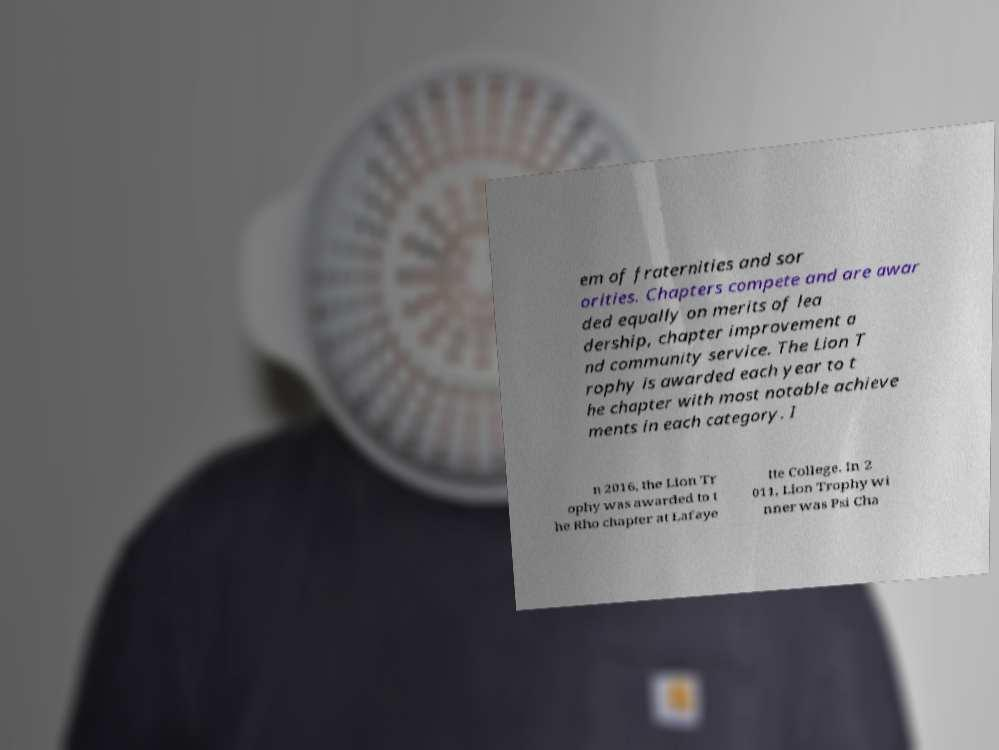Could you extract and type out the text from this image? em of fraternities and sor orities. Chapters compete and are awar ded equally on merits of lea dership, chapter improvement a nd community service. The Lion T rophy is awarded each year to t he chapter with most notable achieve ments in each category. I n 2016, the Lion Tr ophy was awarded to t he Rho chapter at Lafaye tte College. In 2 011, Lion Trophy wi nner was Psi Cha 